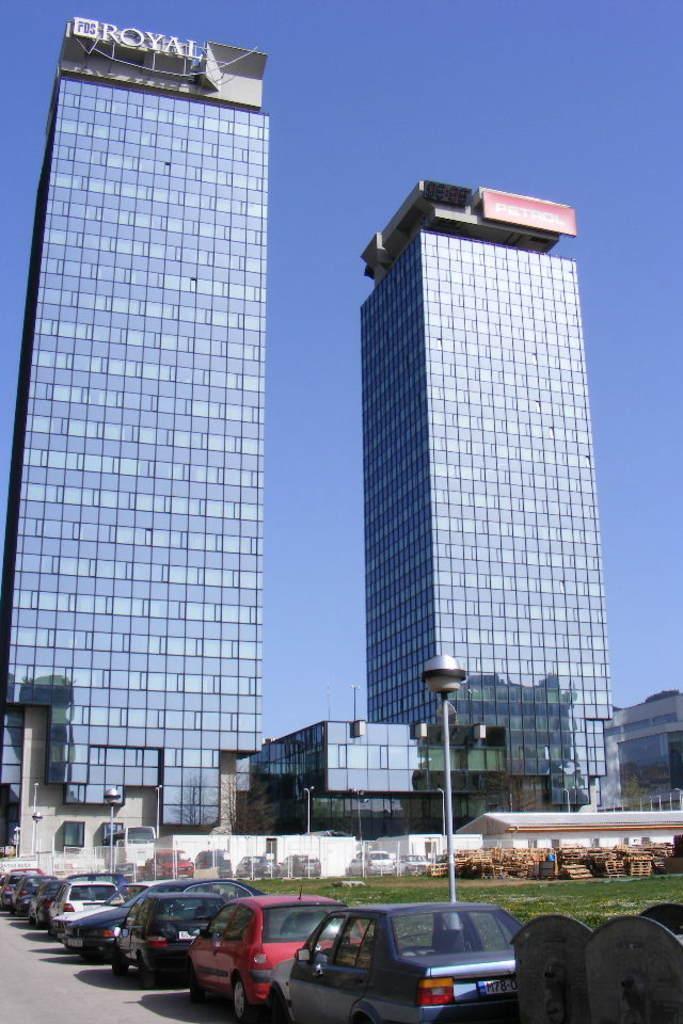How would you summarize this image in a sentence or two? In this picture we can see some vehicles parked on the road and on the right side of the vehicles there are poles with lights. In front of the vehicles there are trees, buildings and the sky and on the buildings there are name boards. 